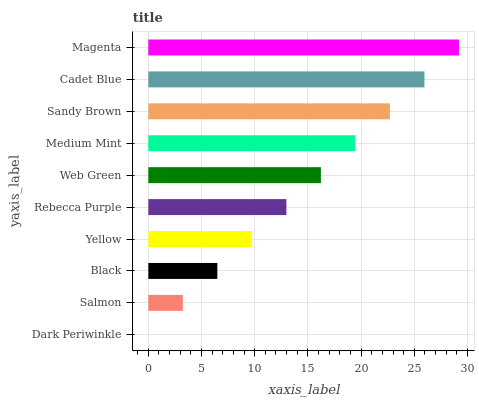Is Dark Periwinkle the minimum?
Answer yes or no. Yes. Is Magenta the maximum?
Answer yes or no. Yes. Is Salmon the minimum?
Answer yes or no. No. Is Salmon the maximum?
Answer yes or no. No. Is Salmon greater than Dark Periwinkle?
Answer yes or no. Yes. Is Dark Periwinkle less than Salmon?
Answer yes or no. Yes. Is Dark Periwinkle greater than Salmon?
Answer yes or no. No. Is Salmon less than Dark Periwinkle?
Answer yes or no. No. Is Web Green the high median?
Answer yes or no. Yes. Is Rebecca Purple the low median?
Answer yes or no. Yes. Is Salmon the high median?
Answer yes or no. No. Is Yellow the low median?
Answer yes or no. No. 